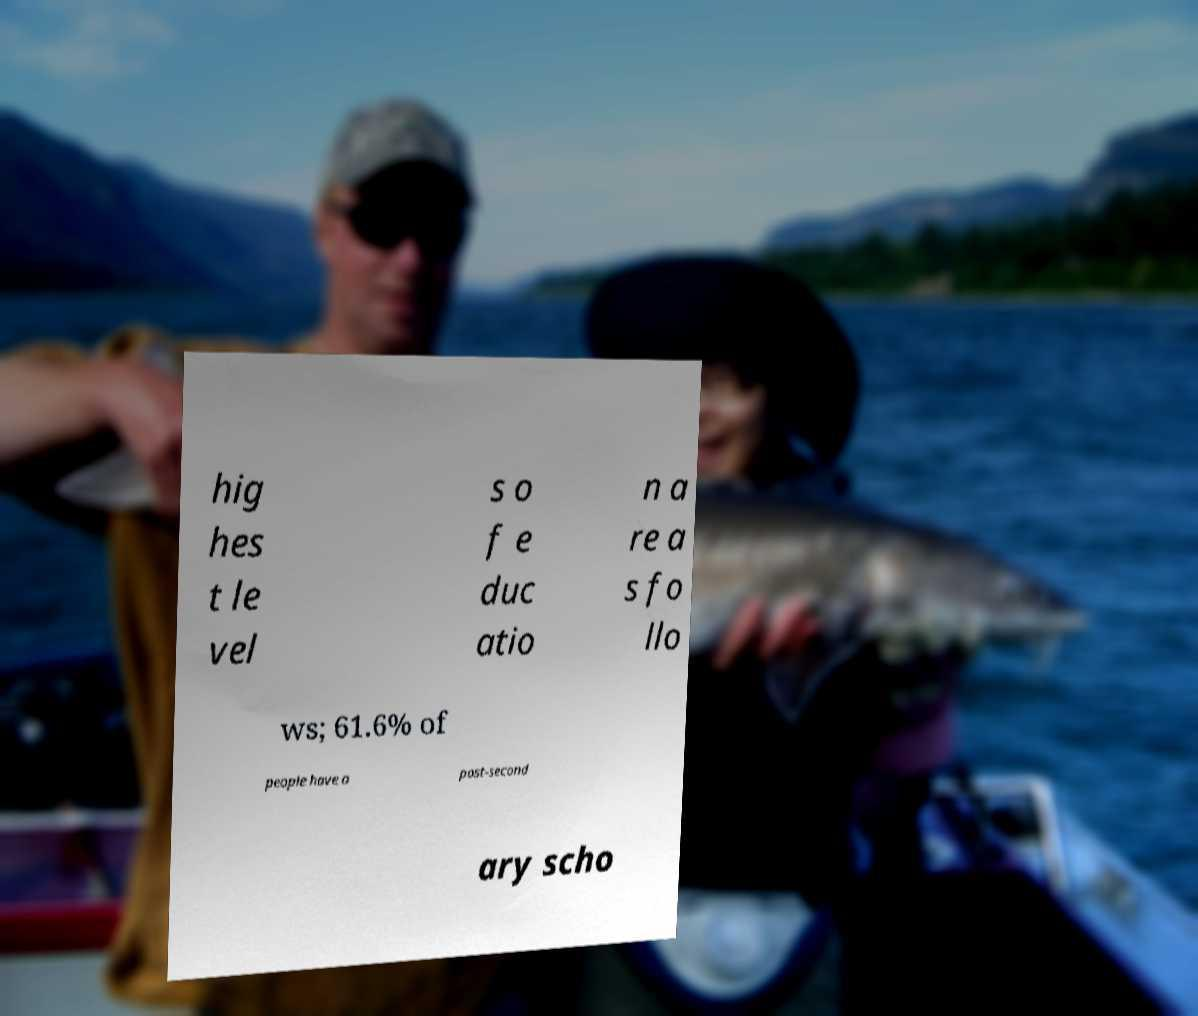I need the written content from this picture converted into text. Can you do that? hig hes t le vel s o f e duc atio n a re a s fo llo ws; 61.6% of people have a post-second ary scho 